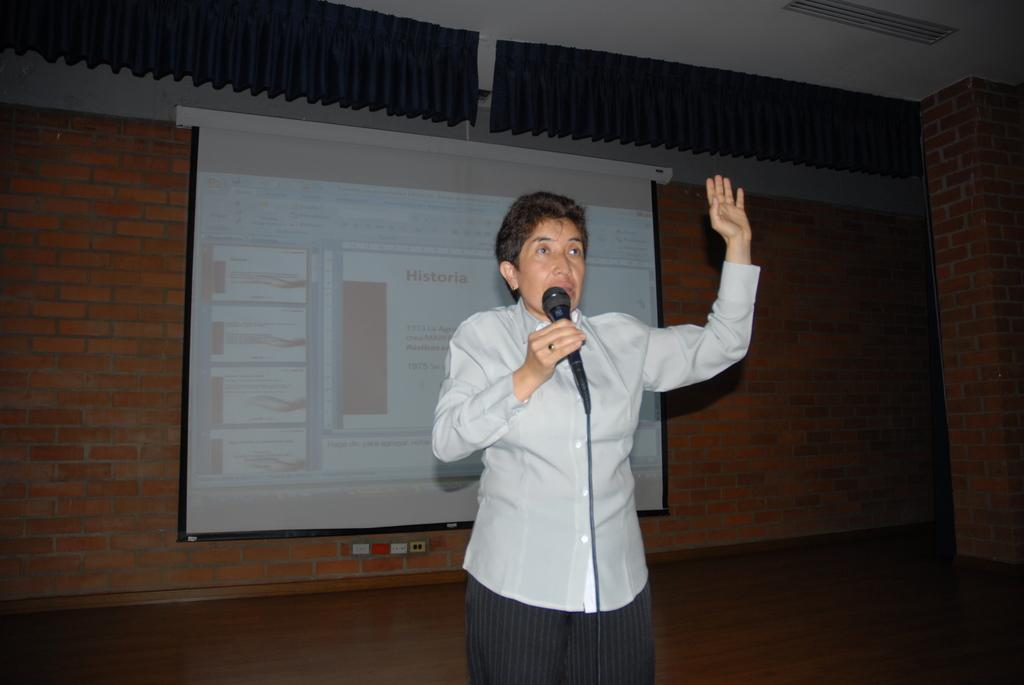What is the person in the image doing? The person is standing in the image and holding a microphone. What can be seen in the background of the image? There is a brick wall and a projector screen in the background of the image. What is displayed on the projector screen? There is text visible on the projector screen. How many cows can be seen in the image? There are no cows present in the image. 